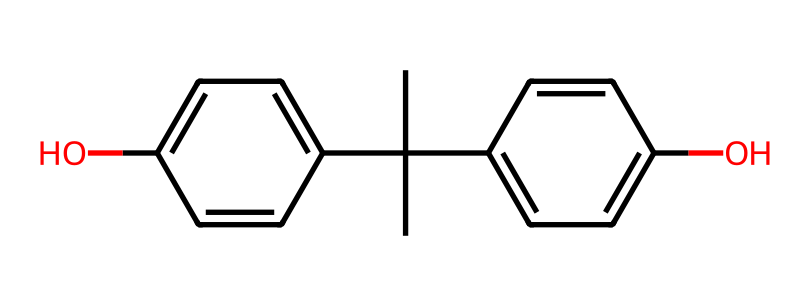What is the chemical name of this compound? The SMILES representation corresponds to bisphenol A, which is an organic compound commonly used in plastics and food packaging. The structure features two phenolic groups linked by a carbon bridge, which is typical for bisphenol compounds.
Answer: bisphenol A How many hydroxyl (-OH) groups are present in this structure? Analyzing the chemical structure, there are two distinct -OH groups attached to the aromatic rings. Each hydroxyl group contributes to the chemical's properties and reactivity.
Answer: 2 What is the primary use of bisphenol A? Bisphenol A is primarily used in the production of polycarbonate plastics and epoxy resins, which are found in various consumer products, including some food containers.
Answer: plastics How many carbon atoms are in this molecule? The SMILES representation shows a total of 15 carbon atoms combined in both the phenolic rings and the non-ring structure, indicating the complexity of bisphenol A.
Answer: 15 What type of chemical is bisphenol A considered? Bisphenol A is considered a synthetic organic compound, specifically categorized as an endocrine disruptor due to its ability to interfere with hormonal functions in living organisms.
Answer: synthetic organic compound Does bisphenol A have any known health concerns? Yes, bisphenol A is associated with various health risks, including hormonal disruptions and potential links to certain chronic diseases and conditions, raising concerns about its safety in consumer products.
Answer: health risks 